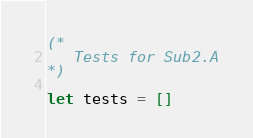Convert code to text. <code><loc_0><loc_0><loc_500><loc_500><_OCaml_>(*
   Tests for Sub2.A
*)

let tests = []
</code> 